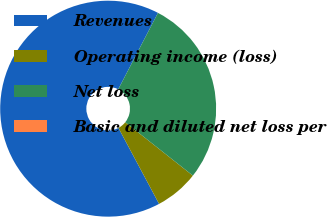Convert chart to OTSL. <chart><loc_0><loc_0><loc_500><loc_500><pie_chart><fcel>Revenues<fcel>Operating income (loss)<fcel>Net loss<fcel>Basic and diluted net loss per<nl><fcel>65.45%<fcel>6.54%<fcel>28.01%<fcel>0.0%<nl></chart> 